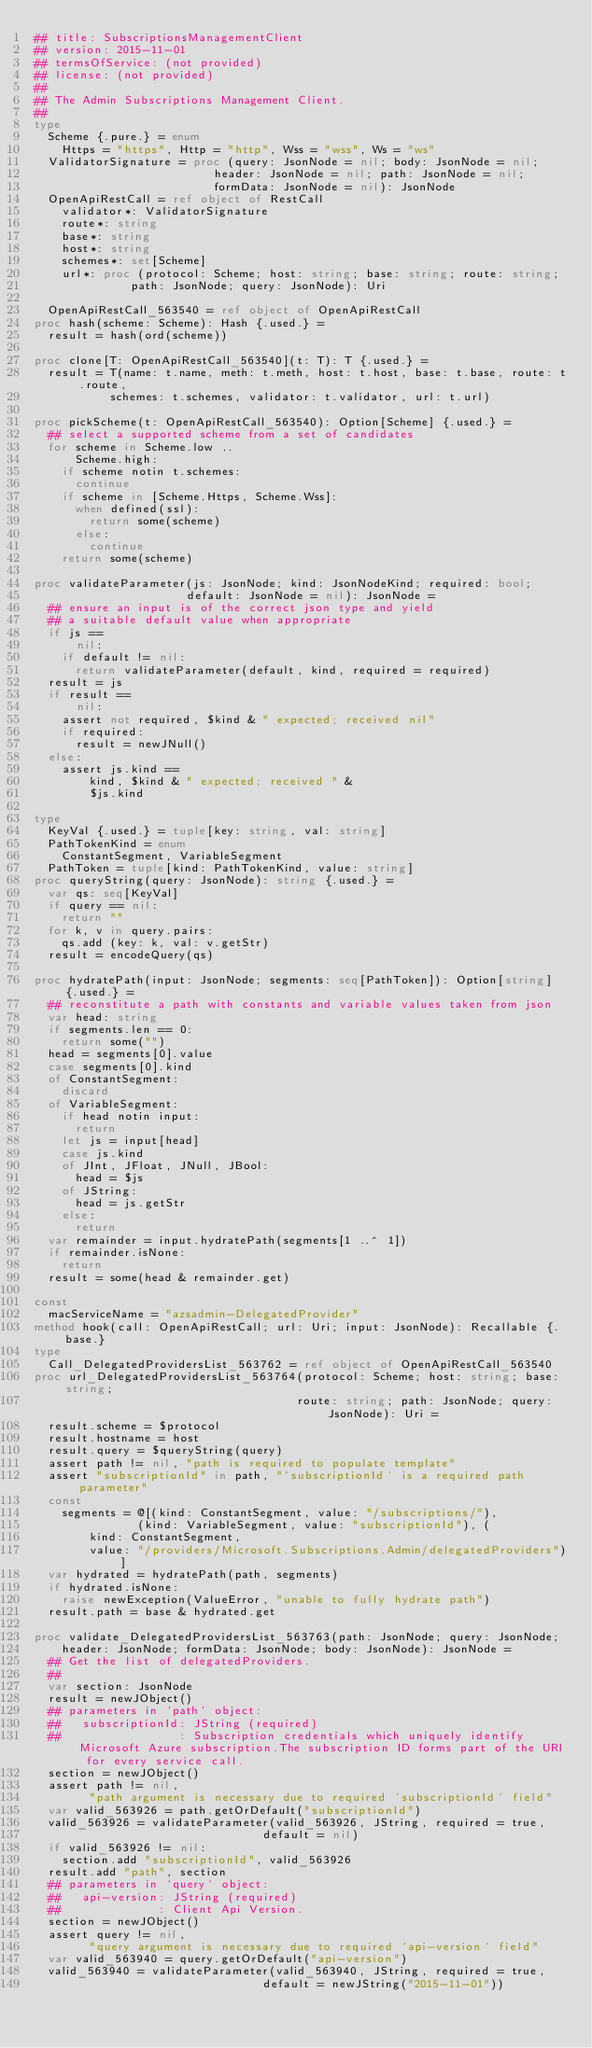Convert code to text. <code><loc_0><loc_0><loc_500><loc_500><_Nim_>## title: SubscriptionsManagementClient
## version: 2015-11-01
## termsOfService: (not provided)
## license: (not provided)
## 
## The Admin Subscriptions Management Client.
## 
type
  Scheme {.pure.} = enum
    Https = "https", Http = "http", Wss = "wss", Ws = "ws"
  ValidatorSignature = proc (query: JsonNode = nil; body: JsonNode = nil;
                          header: JsonNode = nil; path: JsonNode = nil;
                          formData: JsonNode = nil): JsonNode
  OpenApiRestCall = ref object of RestCall
    validator*: ValidatorSignature
    route*: string
    base*: string
    host*: string
    schemes*: set[Scheme]
    url*: proc (protocol: Scheme; host: string; base: string; route: string;
              path: JsonNode; query: JsonNode): Uri

  OpenApiRestCall_563540 = ref object of OpenApiRestCall
proc hash(scheme: Scheme): Hash {.used.} =
  result = hash(ord(scheme))

proc clone[T: OpenApiRestCall_563540](t: T): T {.used.} =
  result = T(name: t.name, meth: t.meth, host: t.host, base: t.base, route: t.route,
           schemes: t.schemes, validator: t.validator, url: t.url)

proc pickScheme(t: OpenApiRestCall_563540): Option[Scheme] {.used.} =
  ## select a supported scheme from a set of candidates
  for scheme in Scheme.low ..
      Scheme.high:
    if scheme notin t.schemes:
      continue
    if scheme in [Scheme.Https, Scheme.Wss]:
      when defined(ssl):
        return some(scheme)
      else:
        continue
    return some(scheme)

proc validateParameter(js: JsonNode; kind: JsonNodeKind; required: bool;
                      default: JsonNode = nil): JsonNode =
  ## ensure an input is of the correct json type and yield
  ## a suitable default value when appropriate
  if js ==
      nil:
    if default != nil:
      return validateParameter(default, kind, required = required)
  result = js
  if result ==
      nil:
    assert not required, $kind & " expected; received nil"
    if required:
      result = newJNull()
  else:
    assert js.kind ==
        kind, $kind & " expected; received " &
        $js.kind

type
  KeyVal {.used.} = tuple[key: string, val: string]
  PathTokenKind = enum
    ConstantSegment, VariableSegment
  PathToken = tuple[kind: PathTokenKind, value: string]
proc queryString(query: JsonNode): string {.used.} =
  var qs: seq[KeyVal]
  if query == nil:
    return ""
  for k, v in query.pairs:
    qs.add (key: k, val: v.getStr)
  result = encodeQuery(qs)

proc hydratePath(input: JsonNode; segments: seq[PathToken]): Option[string] {.used.} =
  ## reconstitute a path with constants and variable values taken from json
  var head: string
  if segments.len == 0:
    return some("")
  head = segments[0].value
  case segments[0].kind
  of ConstantSegment:
    discard
  of VariableSegment:
    if head notin input:
      return
    let js = input[head]
    case js.kind
    of JInt, JFloat, JNull, JBool:
      head = $js
    of JString:
      head = js.getStr
    else:
      return
  var remainder = input.hydratePath(segments[1 ..^ 1])
  if remainder.isNone:
    return
  result = some(head & remainder.get)

const
  macServiceName = "azsadmin-DelegatedProvider"
method hook(call: OpenApiRestCall; url: Uri; input: JsonNode): Recallable {.base.}
type
  Call_DelegatedProvidersList_563762 = ref object of OpenApiRestCall_563540
proc url_DelegatedProvidersList_563764(protocol: Scheme; host: string; base: string;
                                      route: string; path: JsonNode; query: JsonNode): Uri =
  result.scheme = $protocol
  result.hostname = host
  result.query = $queryString(query)
  assert path != nil, "path is required to populate template"
  assert "subscriptionId" in path, "`subscriptionId` is a required path parameter"
  const
    segments = @[(kind: ConstantSegment, value: "/subscriptions/"),
               (kind: VariableSegment, value: "subscriptionId"), (
        kind: ConstantSegment,
        value: "/providers/Microsoft.Subscriptions.Admin/delegatedProviders")]
  var hydrated = hydratePath(path, segments)
  if hydrated.isNone:
    raise newException(ValueError, "unable to fully hydrate path")
  result.path = base & hydrated.get

proc validate_DelegatedProvidersList_563763(path: JsonNode; query: JsonNode;
    header: JsonNode; formData: JsonNode; body: JsonNode): JsonNode =
  ## Get the list of delegatedProviders.
  ## 
  var section: JsonNode
  result = newJObject()
  ## parameters in `path` object:
  ##   subscriptionId: JString (required)
  ##                 : Subscription credentials which uniquely identify Microsoft Azure subscription.The subscription ID forms part of the URI for every service call.
  section = newJObject()
  assert path != nil,
        "path argument is necessary due to required `subscriptionId` field"
  var valid_563926 = path.getOrDefault("subscriptionId")
  valid_563926 = validateParameter(valid_563926, JString, required = true,
                                 default = nil)
  if valid_563926 != nil:
    section.add "subscriptionId", valid_563926
  result.add "path", section
  ## parameters in `query` object:
  ##   api-version: JString (required)
  ##              : Client Api Version.
  section = newJObject()
  assert query != nil,
        "query argument is necessary due to required `api-version` field"
  var valid_563940 = query.getOrDefault("api-version")
  valid_563940 = validateParameter(valid_563940, JString, required = true,
                                 default = newJString("2015-11-01"))</code> 